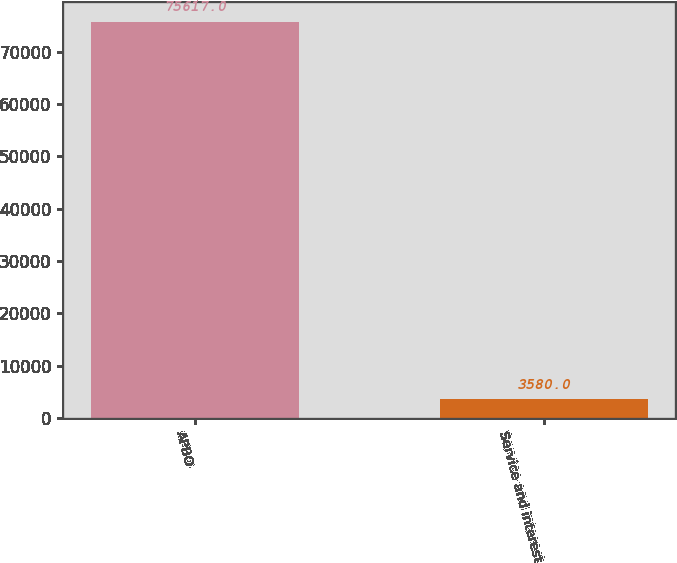<chart> <loc_0><loc_0><loc_500><loc_500><bar_chart><fcel>APBO<fcel>Service and interest<nl><fcel>75617<fcel>3580<nl></chart> 